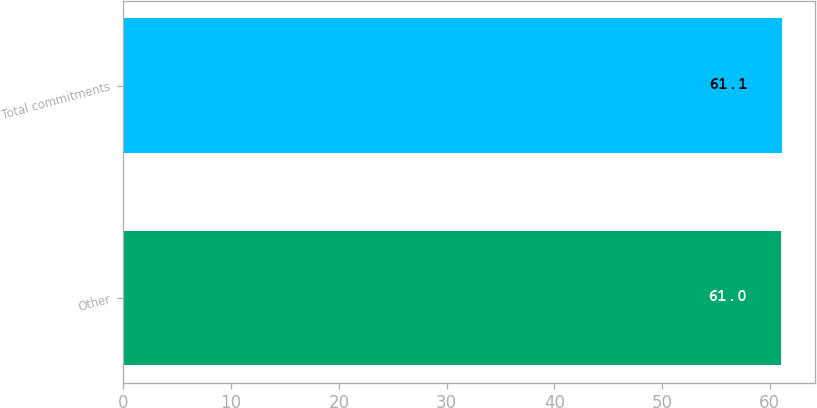Convert chart. <chart><loc_0><loc_0><loc_500><loc_500><bar_chart><fcel>Other<fcel>Total commitments<nl><fcel>61<fcel>61.1<nl></chart> 